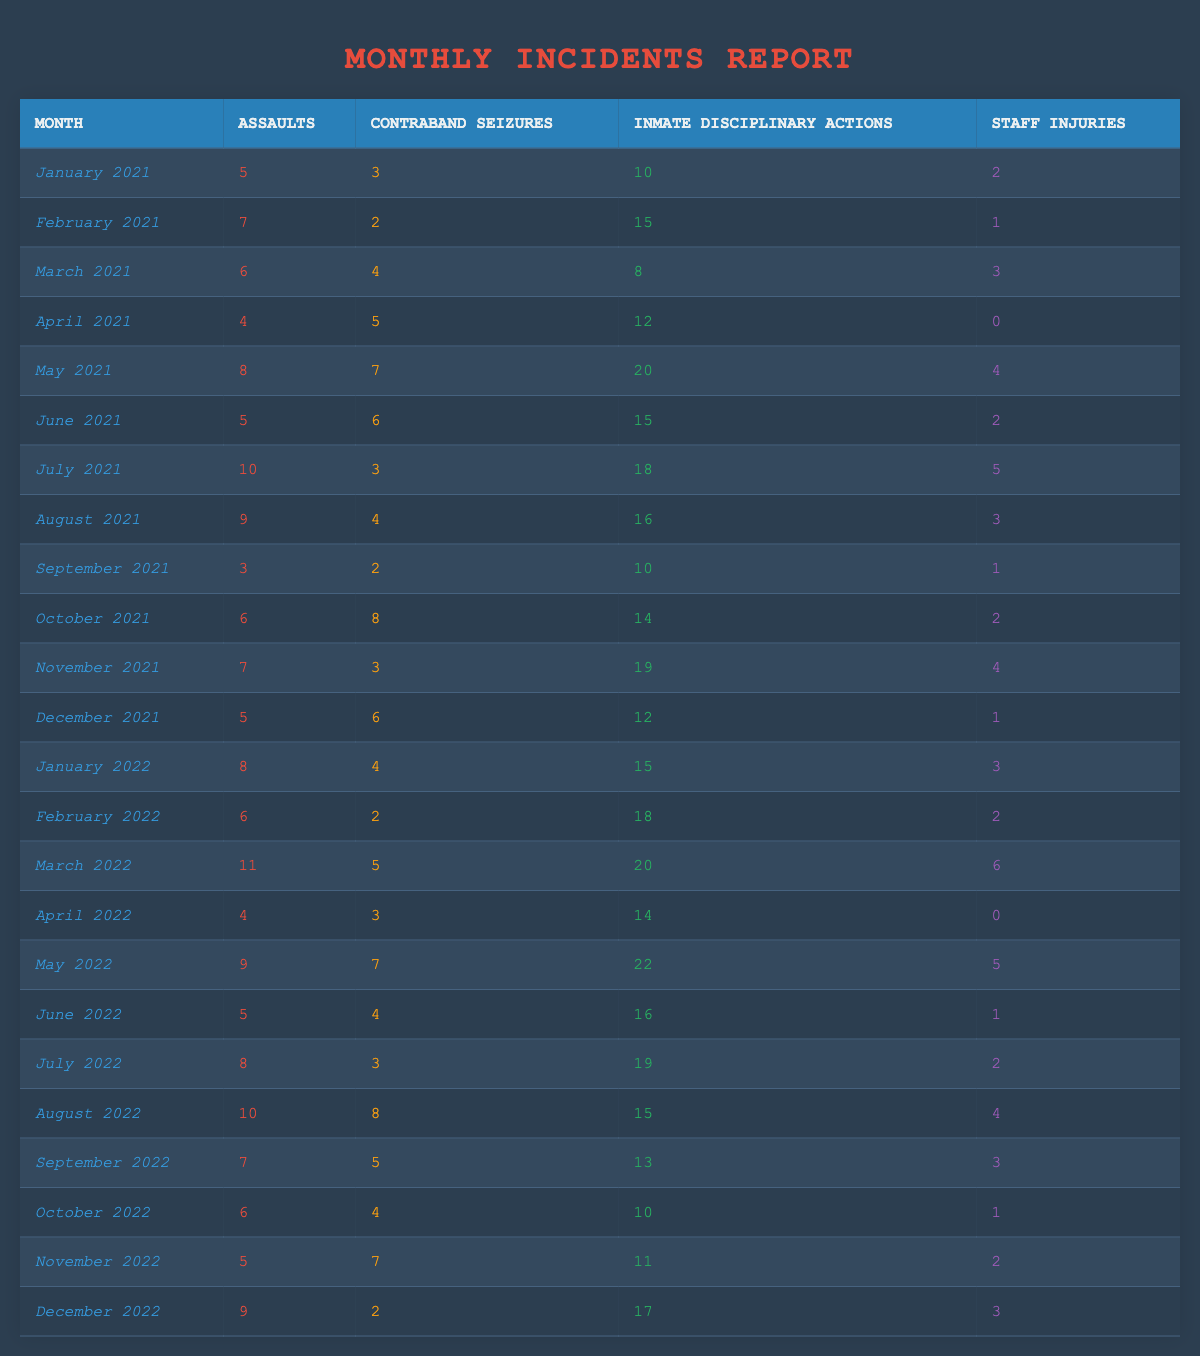What month had the highest number of assaults? By looking through the table, the month with the highest number of assaults is March 2022, which reported 11 assaults.
Answer: March 2022 How many staff injuries were reported in total over these two years? To find the total staff injuries, sum the staff injuries from each month: (2 + 1 + 3 + 0 + 4 + 2 + 5 + 3 + 1 + 2 + 4 + 1 + 3 + 2 + 6 + 0 + 5 + 1 + 2 + 4 + 3 + 1 + 2 + 3) = 66.
Answer: 66 Was there a month in 2021 where the number of contraband seizures was greater than 5? Yes, May 2021 had 7 contraband seizures, which is greater than 5.
Answer: Yes What was the average number of assaults per month in 2021? There are 12 months in 2021; the total number of assaults is 5 + 7 + 6 + 4 + 8 + 5 + 10 + 9 + 3 + 6 + 7 + 5 = 70. The average is 70/12 = 5.83 (approximately).
Answer: Approximately 5.83 In which month was the highest number of inmate disciplinary actions recorded? The month with the highest number of inmate disciplinary actions is May 2022, which recorded 22 actions.
Answer: May 2022 How many months had more than 15 inmate disciplinary actions? By checking each month, the months with more than 15 inmate disciplinary actions are: May 2021 (20), July 2021 (18), November 2021 (19), March 2022 (20), May 2022 (22), and July 2022 (19), totaling 6 months.
Answer: 6 months What percentage of months reported 0 staff injuries? There are 24 months total in the data, and 2 of those months (April 2021 and April 2022) reported 0 staff injuries; thus, the percentage is (2/24) * 100 = 8.33%.
Answer: 8.33% If we consider the number of contraband seizures in 2022, which month had the least? By reviewing the table, April 2022 had the least contraband seizures with only 3 reported.
Answer: April 2022 How did the total number of assaults in 2022 compare to 2021? In 2021, total assaults were 70 and in 2022, they were 69. 2021 had 1 more assault than 2022.
Answer: 2021 had 1 more assault Which month showed a decrease in both assaults and contraband seizures compared to the previous month? August 2021 showed a decrease in assaults (9 from 10) and contraband seizures (4 from 3). August 2022 also showed a decrease in assaults (10 from 11) and contraband seizures (8 from 7).
Answer: August 2021 and August 2022 